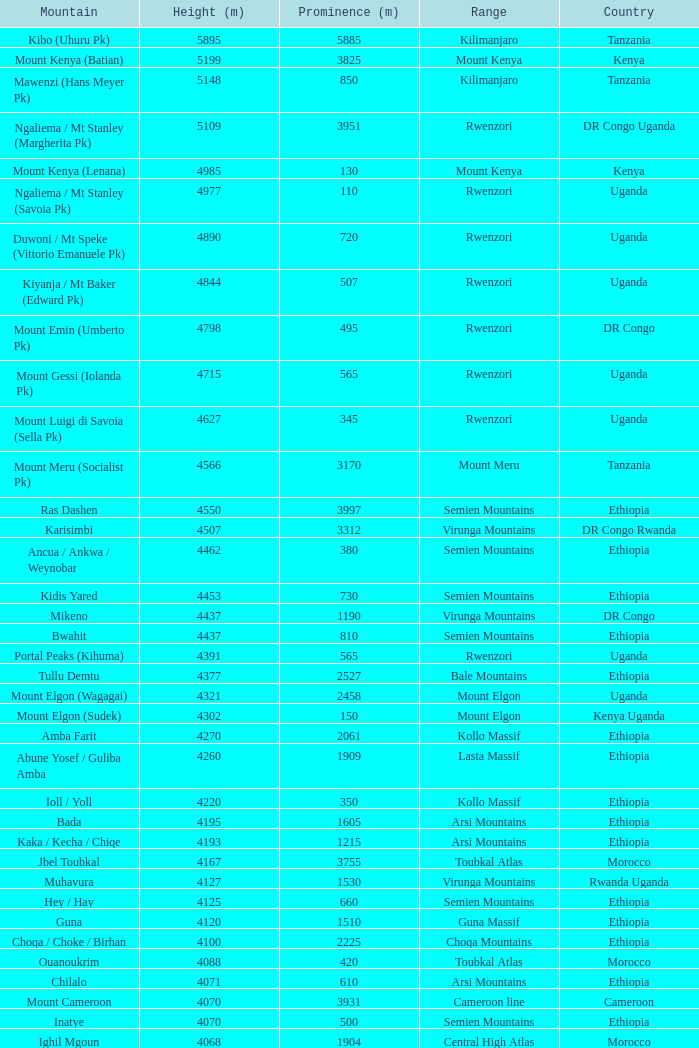Which Country has a Prominence (m) smaller than 1540, and a Height (m) smaller than 3530, and a Range of virunga mountains, and a Mountain of nyiragongo? DR Congo. Could you parse the entire table? {'header': ['Mountain', 'Height (m)', 'Prominence (m)', 'Range', 'Country'], 'rows': [['Kibo (Uhuru Pk)', '5895', '5885', 'Kilimanjaro', 'Tanzania'], ['Mount Kenya (Batian)', '5199', '3825', 'Mount Kenya', 'Kenya'], ['Mawenzi (Hans Meyer Pk)', '5148', '850', 'Kilimanjaro', 'Tanzania'], ['Ngaliema / Mt Stanley (Margherita Pk)', '5109', '3951', 'Rwenzori', 'DR Congo Uganda'], ['Mount Kenya (Lenana)', '4985', '130', 'Mount Kenya', 'Kenya'], ['Ngaliema / Mt Stanley (Savoia Pk)', '4977', '110', 'Rwenzori', 'Uganda'], ['Duwoni / Mt Speke (Vittorio Emanuele Pk)', '4890', '720', 'Rwenzori', 'Uganda'], ['Kiyanja / Mt Baker (Edward Pk)', '4844', '507', 'Rwenzori', 'Uganda'], ['Mount Emin (Umberto Pk)', '4798', '495', 'Rwenzori', 'DR Congo'], ['Mount Gessi (Iolanda Pk)', '4715', '565', 'Rwenzori', 'Uganda'], ['Mount Luigi di Savoia (Sella Pk)', '4627', '345', 'Rwenzori', 'Uganda'], ['Mount Meru (Socialist Pk)', '4566', '3170', 'Mount Meru', 'Tanzania'], ['Ras Dashen', '4550', '3997', 'Semien Mountains', 'Ethiopia'], ['Karisimbi', '4507', '3312', 'Virunga Mountains', 'DR Congo Rwanda'], ['Ancua / Ankwa / Weynobar', '4462', '380', 'Semien Mountains', 'Ethiopia'], ['Kidis Yared', '4453', '730', 'Semien Mountains', 'Ethiopia'], ['Mikeno', '4437', '1190', 'Virunga Mountains', 'DR Congo'], ['Bwahit', '4437', '810', 'Semien Mountains', 'Ethiopia'], ['Portal Peaks (Kihuma)', '4391', '565', 'Rwenzori', 'Uganda'], ['Tullu Demtu', '4377', '2527', 'Bale Mountains', 'Ethiopia'], ['Mount Elgon (Wagagai)', '4321', '2458', 'Mount Elgon', 'Uganda'], ['Mount Elgon (Sudek)', '4302', '150', 'Mount Elgon', 'Kenya Uganda'], ['Amba Farit', '4270', '2061', 'Kollo Massif', 'Ethiopia'], ['Abune Yosef / Guliba Amba', '4260', '1909', 'Lasta Massif', 'Ethiopia'], ['Ioll / Yoll', '4220', '350', 'Kollo Massif', 'Ethiopia'], ['Bada', '4195', '1605', 'Arsi Mountains', 'Ethiopia'], ['Kaka / Kecha / Chiqe', '4193', '1215', 'Arsi Mountains', 'Ethiopia'], ['Jbel Toubkal', '4167', '3755', 'Toubkal Atlas', 'Morocco'], ['Muhavura', '4127', '1530', 'Virunga Mountains', 'Rwanda Uganda'], ['Hey / Hay', '4125', '660', 'Semien Mountains', 'Ethiopia'], ['Guna', '4120', '1510', 'Guna Massif', 'Ethiopia'], ['Choqa / Choke / Birhan', '4100', '2225', 'Choqa Mountains', 'Ethiopia'], ['Ouanoukrim', '4088', '420', 'Toubkal Atlas', 'Morocco'], ['Chilalo', '4071', '610', 'Arsi Mountains', 'Ethiopia'], ['Mount Cameroon', '4070', '3931', 'Cameroon line', 'Cameroon'], ['Inatye', '4070', '500', 'Semien Mountains', 'Ethiopia'], ['Ighil Mgoun', '4068', '1904', 'Central High Atlas', 'Morocco'], ['Weshema / Wasema?', '4030', '420', 'Bale Mountains', 'Ethiopia'], ['Oldoinyo Lesatima', '4001', '2081', 'Aberdare Range', 'Kenya'], ["Jebel n'Tarourt / Tifnout / Iferouane", '3996', '910', 'Toubkal Atlas', 'Morocco'], ['Muggia', '3950', '500', 'Lasta Massif', 'Ethiopia'], ['Dubbai', '3941', '1540', 'Tigray Mountains', 'Ethiopia'], ['Taska n’Zat', '3912', '460', 'Toubkal Atlas', 'Morocco'], ['Aksouâl', '3903', '450', 'Toubkal Atlas', 'Morocco'], ['Mount Kinangop', '3902', '530', 'Aberdare Range', 'Kenya'], ['Cimbia', '3900', '590', 'Kollo Massif', 'Ethiopia'], ['Anrhemer / Ingehmar', '3892', '380', 'Toubkal Atlas', 'Morocco'], ['Ieciuol ?', '3840', '560', 'Kollo Massif', 'Ethiopia'], ['Kawa / Caua / Lajo', '3830', '475', 'Bale Mountains', 'Ethiopia'], ['Pt 3820', '3820', '450', 'Kollo Massif', 'Ethiopia'], ['Jbel Tignousti', '3819', '930', 'Central High Atlas', 'Morocco'], ['Filfo / Encuolo', '3805', '770', 'Arsi Mountains', 'Ethiopia'], ['Kosso Amba', '3805', '530', 'Lasta Massif', 'Ethiopia'], ['Jbel Ghat', '3781', '470', 'Central High Atlas', 'Morocco'], ['Baylamtu / Gavsigivla', '3777', '1120', 'Lasta Massif', 'Ethiopia'], ['Ouaougoulzat', '3763', '860', 'Central High Atlas', 'Morocco'], ['Somkaru', '3760', '530', 'Bale Mountains', 'Ethiopia'], ['Abieri', '3750', '780', 'Semien Mountains', 'Ethiopia'], ['Arin Ayachi', '3747', '1400', 'East High Atlas', 'Morocco'], ['Teide', '3718', '3718', 'Tenerife', 'Canary Islands'], ['Visoke / Bisoke', '3711', '585', 'Virunga Mountains', 'DR Congo Rwanda'], ['Sarenga', '3700', '1160', 'Tigray Mountains', 'Ethiopia'], ['Woti / Uoti', '3700', '1050', 'Eastern Escarpment', 'Ethiopia'], ['Pt 3700 (Kulsa?)', '3700', '490', 'Arsi Mountains', 'Ethiopia'], ['Loolmalassin', '3682', '2040', 'Crater Highlands', 'Tanzania'], ['Biala ?', '3680', '870', 'Lasta Massif', 'Ethiopia'], ['Azurki / Azourki', '3677', '790', 'Central High Atlas', 'Morocco'], ['Pt 3645', '3645', '910', 'Lasta Massif', 'Ethiopia'], ['Sabyinyo', '3634', '1010', 'Virunga Mountains', 'Rwanda DR Congo Uganda'], ['Mount Gurage / Guraghe', '3620', '1400', 'Gurage Mountains', 'Ethiopia'], ['Angour', '3616', '444', 'Toubkal Atlas', 'Morocco'], ['Jbel Igdat', '3615', '1609', 'West High Atlas', 'Morocco'], ["Jbel n'Anghomar", '3609', '1420', 'Central High Atlas', 'Morocco'], ['Yegura / Amba Moka', '3605', '420', 'Lasta Massif', 'Ethiopia'], ['Pt 3600 (Kitir?)', '3600', '870', 'Eastern Escarpment', 'Ethiopia'], ['Pt 3600', '3600', '610', 'Lasta Massif', 'Ethiopia'], ['Bar Meda high point', '3580', '520', 'Eastern Escarpment', 'Ethiopia'], ['Jbel Erdouz', '3579', '690', 'West High Atlas', 'Morocco'], ['Mount Gugu', '3570', '940', 'Mount Gugu', 'Ethiopia'], ['Gesh Megal (?)', '3570', '520', 'Gurage Mountains', 'Ethiopia'], ['Gughe', '3568', '2013', 'Balta Mountains', 'Ethiopia'], ['Megezez', '3565', '690', 'Eastern Escarpment', 'Ethiopia'], ['Pt 3555', '3555', '475', 'Lasta Massif', 'Ethiopia'], ['Jbel Tinergwet', '3551', '880', 'West High Atlas', 'Morocco'], ['Amba Alagi', '3550', '820', 'Tigray Mountains', 'Ethiopia'], ['Nakugen', '3530', '1510', 'Cherangany Hills', 'Kenya'], ['Gara Guda /Kara Gada', '3530', '900', 'Salale Mountains', 'Ethiopia'], ['Amonewas', '3530', '870', 'Choqa Mountains', 'Ethiopia'], ['Amedamit', '3530', '760', 'Choqa Mountains', 'Ethiopia'], ['Igoudamene', '3519', '550', 'Central High Atlas', 'Morocco'], ['Abuye Meda', '3505', '230', 'Eastern Escarpment', 'Ethiopia'], ['Thabana Ntlenyana', '3482', '2390', 'Drakensberg', 'Lesotho'], ['Mont Mohi', '3480', '1592', 'Mitumba Mountains', 'DR Congo'], ['Gahinga', '3474', '425', 'Virunga Mountains', 'Uganda Rwanda'], ['Nyiragongo', '3470', '1440', 'Virunga Mountains', 'DR Congo']]} 